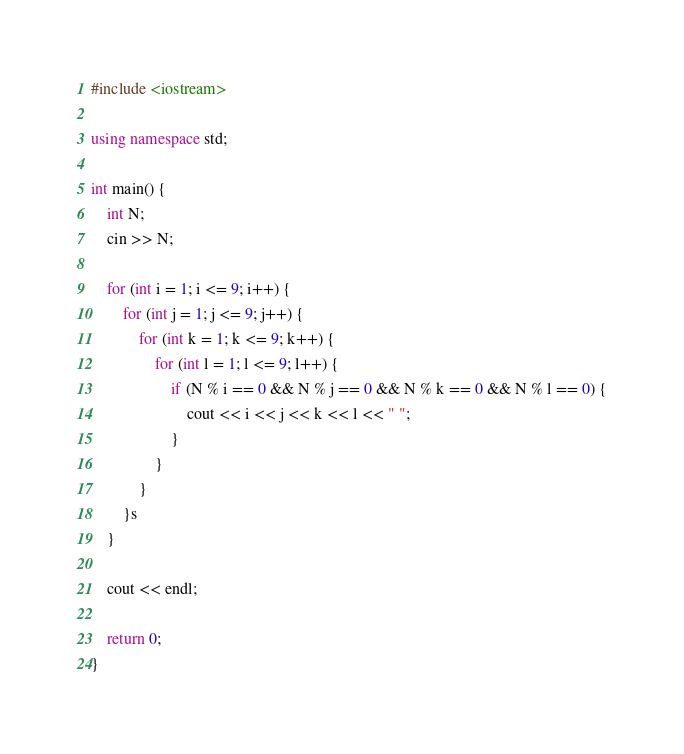Convert code to text. <code><loc_0><loc_0><loc_500><loc_500><_C++_>#include <iostream>

using namespace std;

int main() {
    int N;
    cin >> N;

    for (int i = 1; i <= 9; i++) {
        for (int j = 1; j <= 9; j++) {
            for (int k = 1; k <= 9; k++) {
                for (int l = 1; l <= 9; l++) {
                    if (N % i == 0 && N % j == 0 && N % k == 0 && N % l == 0) {
                        cout << i << j << k << l << " ";
                    }
                }
            }
        }s
    }

    cout << endl;

    return 0;
}
</code> 